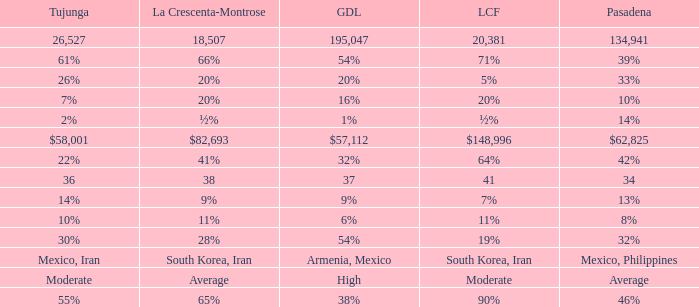What is the figure for La Canada Flintridge when Pasadena is 34? 41.0. 